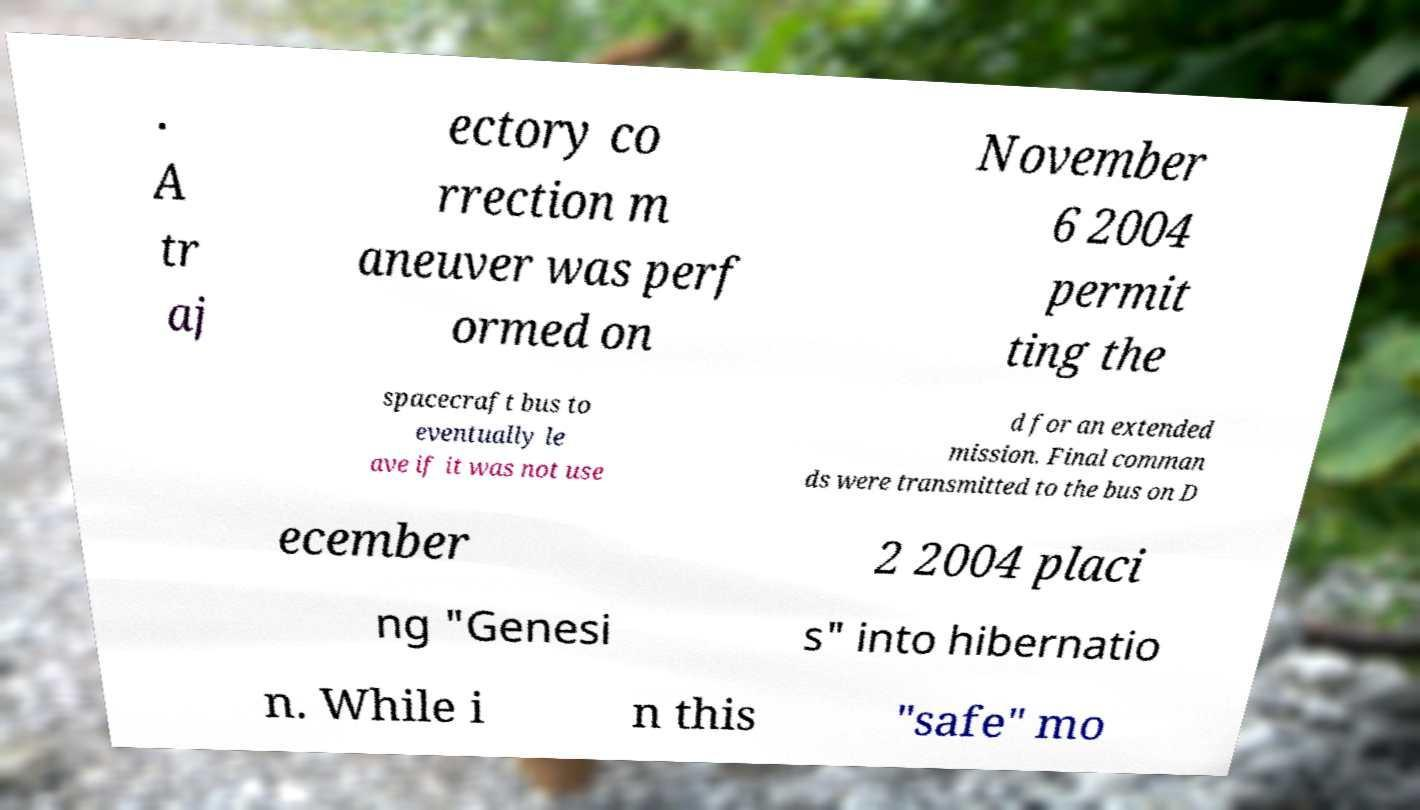There's text embedded in this image that I need extracted. Can you transcribe it verbatim? . A tr aj ectory co rrection m aneuver was perf ormed on November 6 2004 permit ting the spacecraft bus to eventually le ave if it was not use d for an extended mission. Final comman ds were transmitted to the bus on D ecember 2 2004 placi ng "Genesi s" into hibernatio n. While i n this "safe" mo 